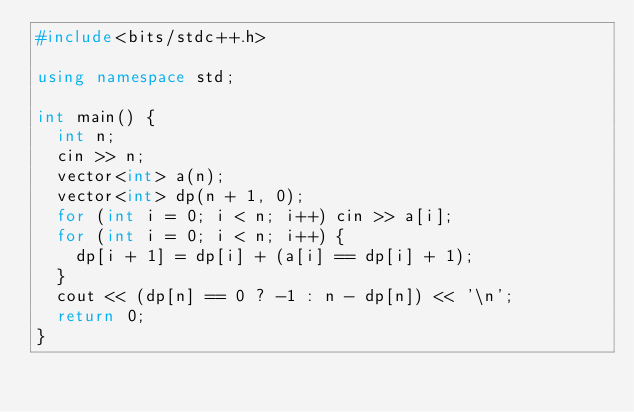Convert code to text. <code><loc_0><loc_0><loc_500><loc_500><_C++_>#include<bits/stdc++.h>

using namespace std;

int main() {
  int n;
  cin >> n;
  vector<int> a(n);
  vector<int> dp(n + 1, 0);
  for (int i = 0; i < n; i++) cin >> a[i];
  for (int i = 0; i < n; i++) {
    dp[i + 1] = dp[i] + (a[i] == dp[i] + 1);
  }
  cout << (dp[n] == 0 ? -1 : n - dp[n]) << '\n';
  return 0;
}
</code> 